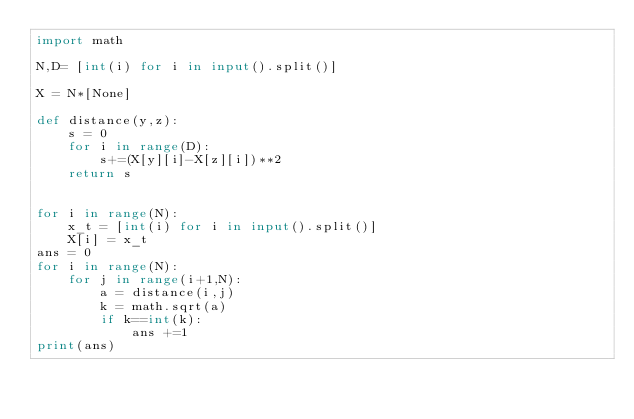Convert code to text. <code><loc_0><loc_0><loc_500><loc_500><_Python_>import math

N,D= [int(i) for i in input().split()]

X = N*[None]

def distance(y,z):
    s = 0
    for i in range(D):
        s+=(X[y][i]-X[z][i])**2
    return s


for i in range(N):
    x_t = [int(i) for i in input().split()]
    X[i] = x_t
ans = 0
for i in range(N):
    for j in range(i+1,N):
        a = distance(i,j)
        k = math.sqrt(a)
        if k==int(k):
            ans +=1
print(ans)</code> 